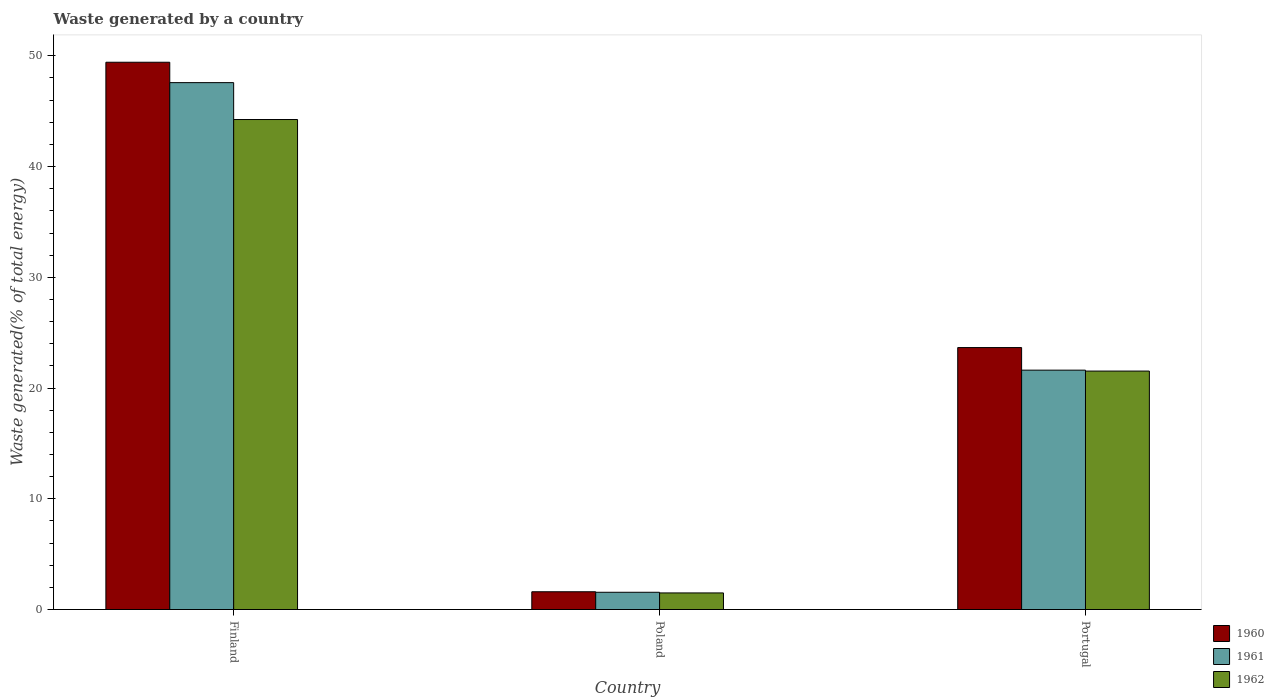Are the number of bars per tick equal to the number of legend labels?
Ensure brevity in your answer.  Yes. How many bars are there on the 3rd tick from the left?
Provide a short and direct response. 3. How many bars are there on the 2nd tick from the right?
Keep it short and to the point. 3. In how many cases, is the number of bars for a given country not equal to the number of legend labels?
Ensure brevity in your answer.  0. What is the total waste generated in 1960 in Poland?
Offer a terse response. 1.6. Across all countries, what is the maximum total waste generated in 1961?
Offer a very short reply. 47.58. Across all countries, what is the minimum total waste generated in 1962?
Give a very brief answer. 1.5. In which country was the total waste generated in 1961 minimum?
Give a very brief answer. Poland. What is the total total waste generated in 1961 in the graph?
Give a very brief answer. 70.76. What is the difference between the total waste generated in 1960 in Finland and that in Portugal?
Your answer should be compact. 25.77. What is the difference between the total waste generated in 1961 in Portugal and the total waste generated in 1960 in Finland?
Make the answer very short. -27.81. What is the average total waste generated in 1962 per country?
Your response must be concise. 22.43. What is the difference between the total waste generated of/in 1960 and total waste generated of/in 1961 in Portugal?
Your answer should be compact. 2.04. In how many countries, is the total waste generated in 1962 greater than 28 %?
Keep it short and to the point. 1. What is the ratio of the total waste generated in 1962 in Finland to that in Portugal?
Provide a short and direct response. 2.05. Is the total waste generated in 1961 in Finland less than that in Portugal?
Your response must be concise. No. What is the difference between the highest and the second highest total waste generated in 1960?
Keep it short and to the point. 47.82. What is the difference between the highest and the lowest total waste generated in 1960?
Provide a short and direct response. 47.82. In how many countries, is the total waste generated in 1961 greater than the average total waste generated in 1961 taken over all countries?
Your response must be concise. 1. What does the 1st bar from the right in Portugal represents?
Provide a succinct answer. 1962. How many bars are there?
Keep it short and to the point. 9. What is the difference between two consecutive major ticks on the Y-axis?
Offer a terse response. 10. Does the graph contain grids?
Your answer should be very brief. No. Where does the legend appear in the graph?
Offer a very short reply. Bottom right. How many legend labels are there?
Give a very brief answer. 3. What is the title of the graph?
Give a very brief answer. Waste generated by a country. What is the label or title of the Y-axis?
Your response must be concise. Waste generated(% of total energy). What is the Waste generated(% of total energy) in 1960 in Finland?
Make the answer very short. 49.42. What is the Waste generated(% of total energy) of 1961 in Finland?
Make the answer very short. 47.58. What is the Waste generated(% of total energy) in 1962 in Finland?
Provide a succinct answer. 44.25. What is the Waste generated(% of total energy) in 1960 in Poland?
Your answer should be compact. 1.6. What is the Waste generated(% of total energy) of 1961 in Poland?
Offer a very short reply. 1.56. What is the Waste generated(% of total energy) in 1962 in Poland?
Ensure brevity in your answer.  1.5. What is the Waste generated(% of total energy) of 1960 in Portugal?
Your answer should be compact. 23.66. What is the Waste generated(% of total energy) in 1961 in Portugal?
Provide a short and direct response. 21.62. What is the Waste generated(% of total energy) of 1962 in Portugal?
Provide a succinct answer. 21.53. Across all countries, what is the maximum Waste generated(% of total energy) in 1960?
Provide a succinct answer. 49.42. Across all countries, what is the maximum Waste generated(% of total energy) of 1961?
Your answer should be compact. 47.58. Across all countries, what is the maximum Waste generated(% of total energy) in 1962?
Offer a terse response. 44.25. Across all countries, what is the minimum Waste generated(% of total energy) in 1960?
Provide a succinct answer. 1.6. Across all countries, what is the minimum Waste generated(% of total energy) in 1961?
Your response must be concise. 1.56. Across all countries, what is the minimum Waste generated(% of total energy) in 1962?
Provide a succinct answer. 1.5. What is the total Waste generated(% of total energy) in 1960 in the graph?
Provide a short and direct response. 74.68. What is the total Waste generated(% of total energy) in 1961 in the graph?
Make the answer very short. 70.76. What is the total Waste generated(% of total energy) of 1962 in the graph?
Offer a terse response. 67.28. What is the difference between the Waste generated(% of total energy) in 1960 in Finland and that in Poland?
Offer a very short reply. 47.82. What is the difference between the Waste generated(% of total energy) in 1961 in Finland and that in Poland?
Ensure brevity in your answer.  46.02. What is the difference between the Waste generated(% of total energy) in 1962 in Finland and that in Poland?
Your response must be concise. 42.75. What is the difference between the Waste generated(% of total energy) in 1960 in Finland and that in Portugal?
Your answer should be very brief. 25.77. What is the difference between the Waste generated(% of total energy) in 1961 in Finland and that in Portugal?
Your answer should be very brief. 25.96. What is the difference between the Waste generated(% of total energy) of 1962 in Finland and that in Portugal?
Your response must be concise. 22.72. What is the difference between the Waste generated(% of total energy) in 1960 in Poland and that in Portugal?
Provide a succinct answer. -22.05. What is the difference between the Waste generated(% of total energy) in 1961 in Poland and that in Portugal?
Keep it short and to the point. -20.06. What is the difference between the Waste generated(% of total energy) of 1962 in Poland and that in Portugal?
Your response must be concise. -20.03. What is the difference between the Waste generated(% of total energy) in 1960 in Finland and the Waste generated(% of total energy) in 1961 in Poland?
Ensure brevity in your answer.  47.86. What is the difference between the Waste generated(% of total energy) of 1960 in Finland and the Waste generated(% of total energy) of 1962 in Poland?
Offer a terse response. 47.92. What is the difference between the Waste generated(% of total energy) in 1961 in Finland and the Waste generated(% of total energy) in 1962 in Poland?
Make the answer very short. 46.08. What is the difference between the Waste generated(% of total energy) in 1960 in Finland and the Waste generated(% of total energy) in 1961 in Portugal?
Your answer should be very brief. 27.81. What is the difference between the Waste generated(% of total energy) of 1960 in Finland and the Waste generated(% of total energy) of 1962 in Portugal?
Provide a short and direct response. 27.89. What is the difference between the Waste generated(% of total energy) in 1961 in Finland and the Waste generated(% of total energy) in 1962 in Portugal?
Give a very brief answer. 26.05. What is the difference between the Waste generated(% of total energy) in 1960 in Poland and the Waste generated(% of total energy) in 1961 in Portugal?
Provide a short and direct response. -20.01. What is the difference between the Waste generated(% of total energy) in 1960 in Poland and the Waste generated(% of total energy) in 1962 in Portugal?
Provide a succinct answer. -19.93. What is the difference between the Waste generated(% of total energy) in 1961 in Poland and the Waste generated(% of total energy) in 1962 in Portugal?
Offer a terse response. -19.98. What is the average Waste generated(% of total energy) in 1960 per country?
Your answer should be compact. 24.89. What is the average Waste generated(% of total energy) of 1961 per country?
Give a very brief answer. 23.59. What is the average Waste generated(% of total energy) in 1962 per country?
Ensure brevity in your answer.  22.43. What is the difference between the Waste generated(% of total energy) in 1960 and Waste generated(% of total energy) in 1961 in Finland?
Provide a succinct answer. 1.84. What is the difference between the Waste generated(% of total energy) of 1960 and Waste generated(% of total energy) of 1962 in Finland?
Provide a short and direct response. 5.17. What is the difference between the Waste generated(% of total energy) of 1961 and Waste generated(% of total energy) of 1962 in Finland?
Your response must be concise. 3.33. What is the difference between the Waste generated(% of total energy) in 1960 and Waste generated(% of total energy) in 1961 in Poland?
Give a very brief answer. 0.05. What is the difference between the Waste generated(% of total energy) in 1960 and Waste generated(% of total energy) in 1962 in Poland?
Offer a very short reply. 0.11. What is the difference between the Waste generated(% of total energy) in 1961 and Waste generated(% of total energy) in 1962 in Poland?
Provide a short and direct response. 0.06. What is the difference between the Waste generated(% of total energy) in 1960 and Waste generated(% of total energy) in 1961 in Portugal?
Provide a succinct answer. 2.04. What is the difference between the Waste generated(% of total energy) of 1960 and Waste generated(% of total energy) of 1962 in Portugal?
Keep it short and to the point. 2.12. What is the difference between the Waste generated(% of total energy) in 1961 and Waste generated(% of total energy) in 1962 in Portugal?
Make the answer very short. 0.08. What is the ratio of the Waste generated(% of total energy) in 1960 in Finland to that in Poland?
Your answer should be compact. 30.8. What is the ratio of the Waste generated(% of total energy) of 1961 in Finland to that in Poland?
Give a very brief answer. 30.53. What is the ratio of the Waste generated(% of total energy) of 1962 in Finland to that in Poland?
Offer a very short reply. 29.52. What is the ratio of the Waste generated(% of total energy) in 1960 in Finland to that in Portugal?
Ensure brevity in your answer.  2.09. What is the ratio of the Waste generated(% of total energy) in 1961 in Finland to that in Portugal?
Make the answer very short. 2.2. What is the ratio of the Waste generated(% of total energy) in 1962 in Finland to that in Portugal?
Provide a succinct answer. 2.05. What is the ratio of the Waste generated(% of total energy) of 1960 in Poland to that in Portugal?
Your answer should be very brief. 0.07. What is the ratio of the Waste generated(% of total energy) in 1961 in Poland to that in Portugal?
Your answer should be very brief. 0.07. What is the ratio of the Waste generated(% of total energy) of 1962 in Poland to that in Portugal?
Make the answer very short. 0.07. What is the difference between the highest and the second highest Waste generated(% of total energy) in 1960?
Your answer should be very brief. 25.77. What is the difference between the highest and the second highest Waste generated(% of total energy) of 1961?
Offer a very short reply. 25.96. What is the difference between the highest and the second highest Waste generated(% of total energy) in 1962?
Ensure brevity in your answer.  22.72. What is the difference between the highest and the lowest Waste generated(% of total energy) in 1960?
Ensure brevity in your answer.  47.82. What is the difference between the highest and the lowest Waste generated(% of total energy) of 1961?
Your answer should be compact. 46.02. What is the difference between the highest and the lowest Waste generated(% of total energy) of 1962?
Offer a very short reply. 42.75. 